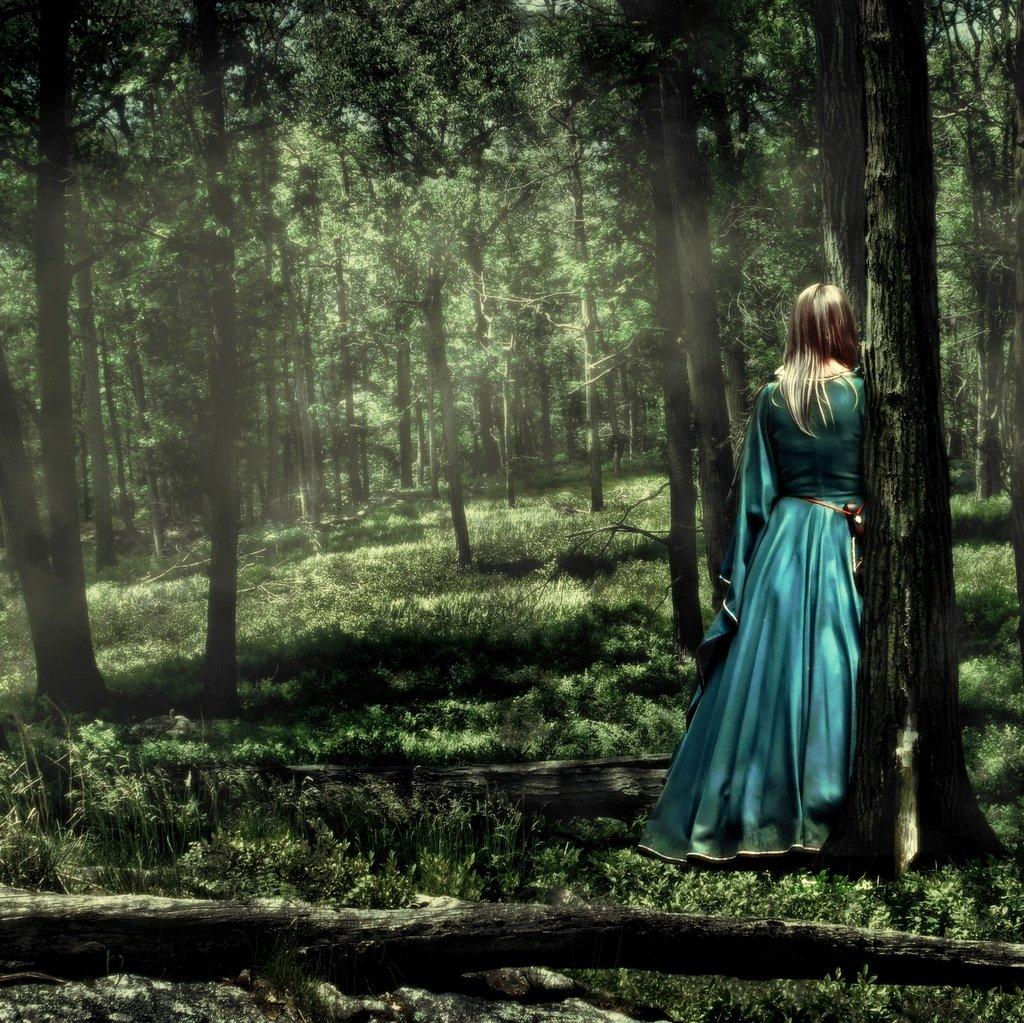What type of vegetation is present in the image? There are trees in the image. Can you describe any specific part of a tree in the image? There is a trunk of a tree in the image. Where is the person located in relation to the trees in the image? There is a person standing in front of a tree on the right side of the image. What type of sugar is being used to sweeten the person's shame in the image? There is no mention of sugar, shame, or any emotional state in the image; it only features trees and a person standing in front of a tree. 